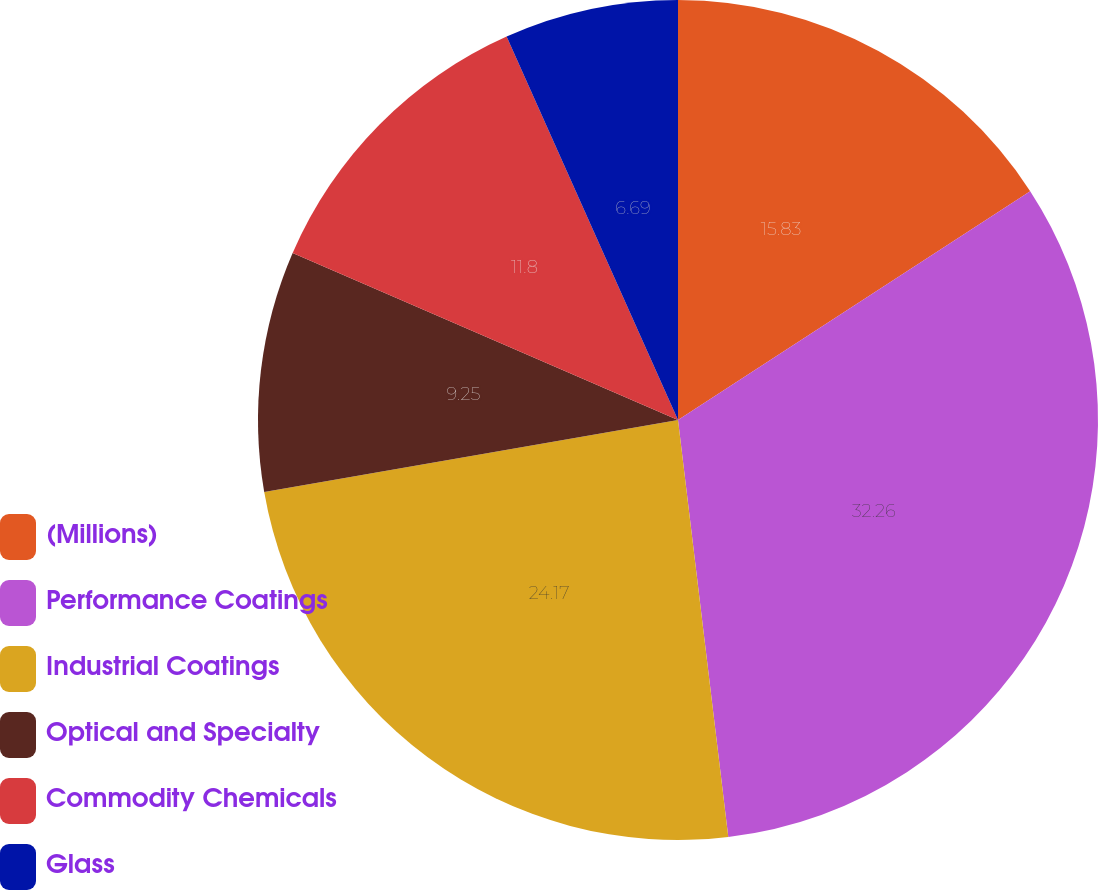<chart> <loc_0><loc_0><loc_500><loc_500><pie_chart><fcel>(Millions)<fcel>Performance Coatings<fcel>Industrial Coatings<fcel>Optical and Specialty<fcel>Commodity Chemicals<fcel>Glass<nl><fcel>15.83%<fcel>32.26%<fcel>24.17%<fcel>9.25%<fcel>11.8%<fcel>6.69%<nl></chart> 